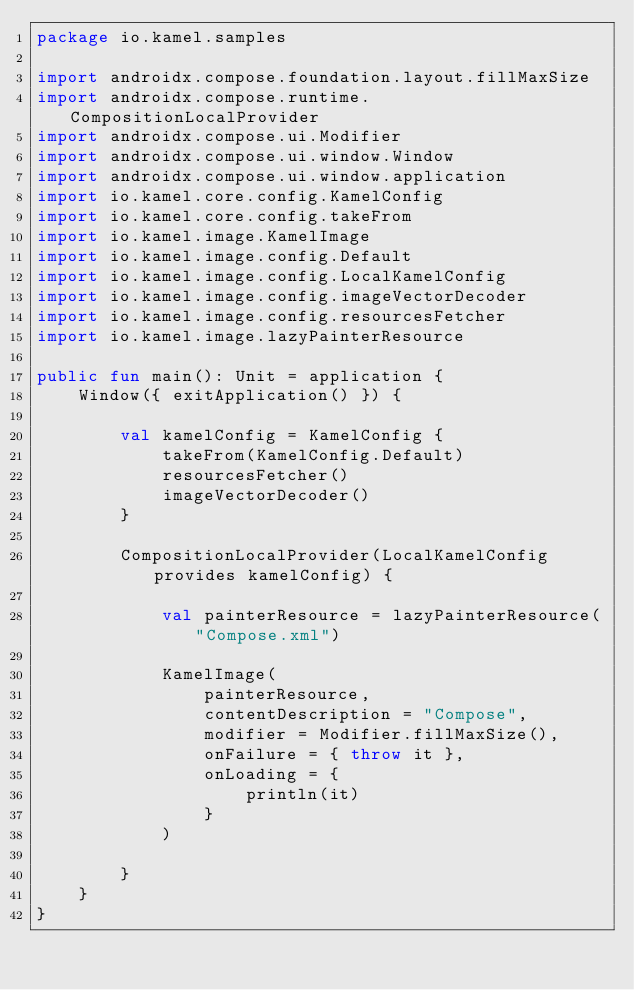Convert code to text. <code><loc_0><loc_0><loc_500><loc_500><_Kotlin_>package io.kamel.samples

import androidx.compose.foundation.layout.fillMaxSize
import androidx.compose.runtime.CompositionLocalProvider
import androidx.compose.ui.Modifier
import androidx.compose.ui.window.Window
import androidx.compose.ui.window.application
import io.kamel.core.config.KamelConfig
import io.kamel.core.config.takeFrom
import io.kamel.image.KamelImage
import io.kamel.image.config.Default
import io.kamel.image.config.LocalKamelConfig
import io.kamel.image.config.imageVectorDecoder
import io.kamel.image.config.resourcesFetcher
import io.kamel.image.lazyPainterResource

public fun main(): Unit = application {
    Window({ exitApplication() }) {

        val kamelConfig = KamelConfig {
            takeFrom(KamelConfig.Default)
            resourcesFetcher()
            imageVectorDecoder()
        }

        CompositionLocalProvider(LocalKamelConfig provides kamelConfig) {

            val painterResource = lazyPainterResource("Compose.xml")

            KamelImage(
                painterResource,
                contentDescription = "Compose",
                modifier = Modifier.fillMaxSize(),
                onFailure = { throw it },
                onLoading = {
                    println(it)
                }
            )

        }
    }
}
</code> 